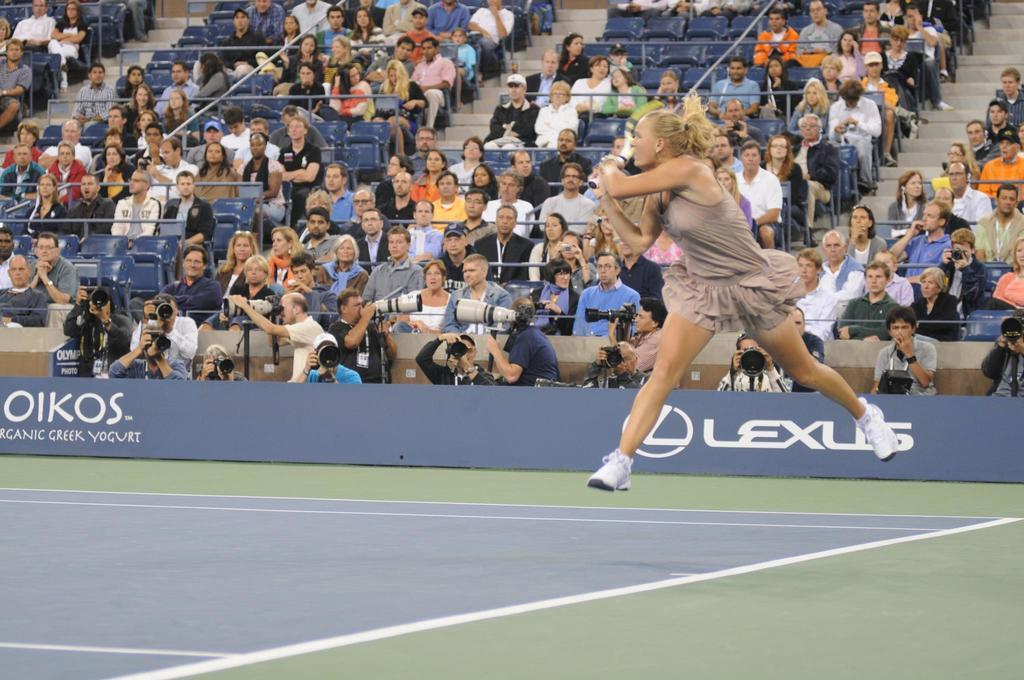What activity is the person in the image engaged in? The person is playing tennis in the image. What object is the tennis player holding? The person is holding a tennis racket. Who else is present in the image besides the tennis player? There are people seated on chairs watching the tennis player, and there are cameramen in the front of the image. What type of locket is the tennis player wearing in the image? There is no locket visible on the tennis player in the image. 